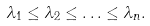Convert formula to latex. <formula><loc_0><loc_0><loc_500><loc_500>\lambda _ { 1 } \leq \lambda _ { 2 } \leq \hdots \leq \lambda _ { n } .</formula> 